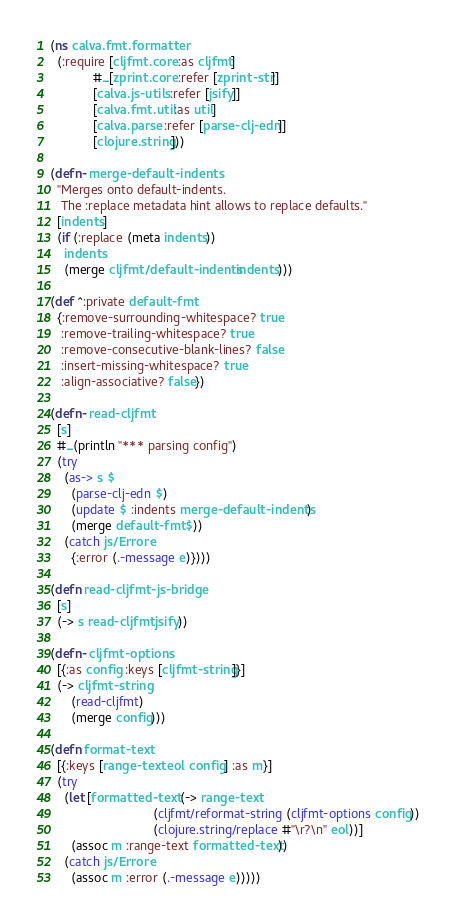<code> <loc_0><loc_0><loc_500><loc_500><_Clojure_>(ns calva.fmt.formatter
  (:require [cljfmt.core :as cljfmt]
            #_[zprint.core :refer [zprint-str]]
            [calva.js-utils :refer [jsify]]
            [calva.fmt.util :as util]
            [calva.parse :refer [parse-clj-edn]]
            [clojure.string]))

(defn- merge-default-indents
  "Merges onto default-indents.
   The :replace metadata hint allows to replace defaults."
  [indents]
  (if (:replace (meta indents))
    indents
    (merge cljfmt/default-indents indents)))

(def ^:private default-fmt
  {:remove-surrounding-whitespace? true
   :remove-trailing-whitespace? true
   :remove-consecutive-blank-lines? false
   :insert-missing-whitespace? true
   :align-associative? false})

(defn- read-cljfmt
  [s]
  #_(println "*** parsing config")
  (try
    (as-> s $
      (parse-clj-edn $)
      (update $ :indents merge-default-indents)
      (merge default-fmt $))
    (catch js/Error e
      {:error (.-message e)})))

(defn read-cljfmt-js-bridge
  [s]
  (-> s read-cljfmt jsify))

(defn- cljfmt-options
  [{:as config :keys [cljfmt-string]}]
  (-> cljfmt-string
      (read-cljfmt)
      (merge config)))

(defn format-text
  [{:keys [range-text eol config] :as m}]
  (try
    (let [formatted-text (-> range-text
                             (cljfmt/reformat-string (cljfmt-options config))
                             (clojure.string/replace #"\r?\n" eol))]
      (assoc m :range-text formatted-text))
    (catch js/Error e
      (assoc m :error (.-message e)))))
</code> 